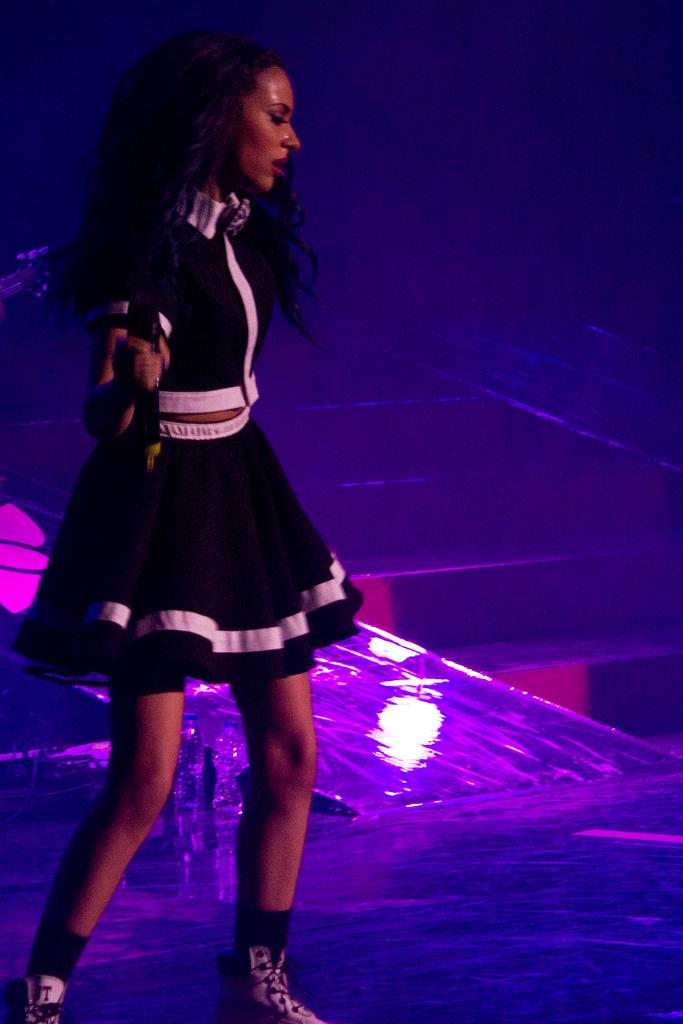What is the main subject of the image? There is a beautiful woman in the image. What is the woman holding in the image? The woman is holding a microphone. What is the woman doing in the image? The woman is dancing. What color is the dress the woman is wearing? The woman is wearing a black dress. What type of duck can be seen swimming in the background of the image? There is no duck present in the image; it features a woman dancing with a microphone. 